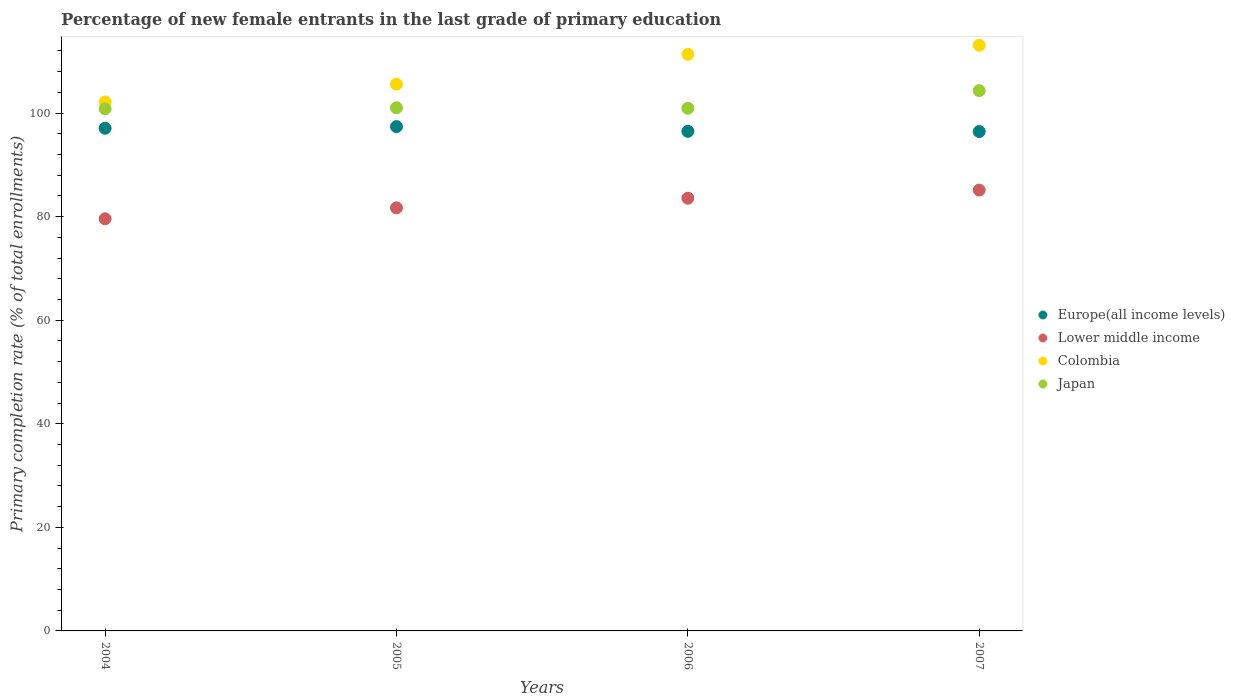Is the number of dotlines equal to the number of legend labels?
Your answer should be compact. Yes. What is the percentage of new female entrants in Japan in 2006?
Provide a short and direct response. 100.92. Across all years, what is the maximum percentage of new female entrants in Japan?
Offer a terse response. 104.33. Across all years, what is the minimum percentage of new female entrants in Colombia?
Your answer should be compact. 102.14. In which year was the percentage of new female entrants in Lower middle income maximum?
Your response must be concise. 2007. What is the total percentage of new female entrants in Lower middle income in the graph?
Provide a short and direct response. 329.95. What is the difference between the percentage of new female entrants in Colombia in 2004 and that in 2006?
Provide a short and direct response. -9.19. What is the difference between the percentage of new female entrants in Europe(all income levels) in 2006 and the percentage of new female entrants in Japan in 2004?
Offer a terse response. -4.35. What is the average percentage of new female entrants in Colombia per year?
Offer a terse response. 108.03. In the year 2005, what is the difference between the percentage of new female entrants in Colombia and percentage of new female entrants in Europe(all income levels)?
Ensure brevity in your answer.  8.2. What is the ratio of the percentage of new female entrants in Lower middle income in 2004 to that in 2005?
Ensure brevity in your answer.  0.97. Is the percentage of new female entrants in Japan in 2006 less than that in 2007?
Give a very brief answer. Yes. What is the difference between the highest and the second highest percentage of new female entrants in Europe(all income levels)?
Your answer should be compact. 0.31. What is the difference between the highest and the lowest percentage of new female entrants in Colombia?
Make the answer very short. 10.94. In how many years, is the percentage of new female entrants in Europe(all income levels) greater than the average percentage of new female entrants in Europe(all income levels) taken over all years?
Offer a very short reply. 2. Is the sum of the percentage of new female entrants in Colombia in 2005 and 2007 greater than the maximum percentage of new female entrants in Lower middle income across all years?
Make the answer very short. Yes. Does the percentage of new female entrants in Europe(all income levels) monotonically increase over the years?
Make the answer very short. No. Is the percentage of new female entrants in Japan strictly greater than the percentage of new female entrants in Colombia over the years?
Make the answer very short. No. Is the percentage of new female entrants in Japan strictly less than the percentage of new female entrants in Colombia over the years?
Your answer should be very brief. Yes. How many dotlines are there?
Your response must be concise. 4. How many years are there in the graph?
Keep it short and to the point. 4. Does the graph contain any zero values?
Ensure brevity in your answer.  No. Does the graph contain grids?
Provide a short and direct response. No. Where does the legend appear in the graph?
Keep it short and to the point. Center right. What is the title of the graph?
Provide a short and direct response. Percentage of new female entrants in the last grade of primary education. What is the label or title of the Y-axis?
Provide a short and direct response. Primary completion rate (% of total enrollments). What is the Primary completion rate (% of total enrollments) in Europe(all income levels) in 2004?
Provide a succinct answer. 97.06. What is the Primary completion rate (% of total enrollments) in Lower middle income in 2004?
Provide a succinct answer. 79.58. What is the Primary completion rate (% of total enrollments) in Colombia in 2004?
Provide a succinct answer. 102.14. What is the Primary completion rate (% of total enrollments) in Japan in 2004?
Your answer should be compact. 100.82. What is the Primary completion rate (% of total enrollments) of Europe(all income levels) in 2005?
Offer a terse response. 97.37. What is the Primary completion rate (% of total enrollments) in Lower middle income in 2005?
Offer a terse response. 81.69. What is the Primary completion rate (% of total enrollments) in Colombia in 2005?
Ensure brevity in your answer.  105.57. What is the Primary completion rate (% of total enrollments) of Japan in 2005?
Your answer should be compact. 101.02. What is the Primary completion rate (% of total enrollments) in Europe(all income levels) in 2006?
Your answer should be very brief. 96.47. What is the Primary completion rate (% of total enrollments) in Lower middle income in 2006?
Ensure brevity in your answer.  83.55. What is the Primary completion rate (% of total enrollments) of Colombia in 2006?
Keep it short and to the point. 111.33. What is the Primary completion rate (% of total enrollments) of Japan in 2006?
Your answer should be very brief. 100.92. What is the Primary completion rate (% of total enrollments) of Europe(all income levels) in 2007?
Your response must be concise. 96.43. What is the Primary completion rate (% of total enrollments) of Lower middle income in 2007?
Make the answer very short. 85.12. What is the Primary completion rate (% of total enrollments) of Colombia in 2007?
Give a very brief answer. 113.09. What is the Primary completion rate (% of total enrollments) in Japan in 2007?
Make the answer very short. 104.33. Across all years, what is the maximum Primary completion rate (% of total enrollments) in Europe(all income levels)?
Offer a very short reply. 97.37. Across all years, what is the maximum Primary completion rate (% of total enrollments) in Lower middle income?
Offer a terse response. 85.12. Across all years, what is the maximum Primary completion rate (% of total enrollments) in Colombia?
Offer a very short reply. 113.09. Across all years, what is the maximum Primary completion rate (% of total enrollments) of Japan?
Ensure brevity in your answer.  104.33. Across all years, what is the minimum Primary completion rate (% of total enrollments) of Europe(all income levels)?
Your response must be concise. 96.43. Across all years, what is the minimum Primary completion rate (% of total enrollments) of Lower middle income?
Your answer should be very brief. 79.58. Across all years, what is the minimum Primary completion rate (% of total enrollments) of Colombia?
Your answer should be very brief. 102.14. Across all years, what is the minimum Primary completion rate (% of total enrollments) of Japan?
Make the answer very short. 100.82. What is the total Primary completion rate (% of total enrollments) of Europe(all income levels) in the graph?
Keep it short and to the point. 387.33. What is the total Primary completion rate (% of total enrollments) of Lower middle income in the graph?
Offer a very short reply. 329.95. What is the total Primary completion rate (% of total enrollments) of Colombia in the graph?
Keep it short and to the point. 432.13. What is the total Primary completion rate (% of total enrollments) of Japan in the graph?
Provide a short and direct response. 407.09. What is the difference between the Primary completion rate (% of total enrollments) of Europe(all income levels) in 2004 and that in 2005?
Keep it short and to the point. -0.31. What is the difference between the Primary completion rate (% of total enrollments) in Lower middle income in 2004 and that in 2005?
Make the answer very short. -2.11. What is the difference between the Primary completion rate (% of total enrollments) of Colombia in 2004 and that in 2005?
Offer a terse response. -3.43. What is the difference between the Primary completion rate (% of total enrollments) in Japan in 2004 and that in 2005?
Provide a succinct answer. -0.2. What is the difference between the Primary completion rate (% of total enrollments) of Europe(all income levels) in 2004 and that in 2006?
Your response must be concise. 0.59. What is the difference between the Primary completion rate (% of total enrollments) in Lower middle income in 2004 and that in 2006?
Your answer should be very brief. -3.97. What is the difference between the Primary completion rate (% of total enrollments) in Colombia in 2004 and that in 2006?
Keep it short and to the point. -9.19. What is the difference between the Primary completion rate (% of total enrollments) of Japan in 2004 and that in 2006?
Keep it short and to the point. -0.1. What is the difference between the Primary completion rate (% of total enrollments) of Europe(all income levels) in 2004 and that in 2007?
Make the answer very short. 0.63. What is the difference between the Primary completion rate (% of total enrollments) of Lower middle income in 2004 and that in 2007?
Your answer should be very brief. -5.54. What is the difference between the Primary completion rate (% of total enrollments) of Colombia in 2004 and that in 2007?
Keep it short and to the point. -10.94. What is the difference between the Primary completion rate (% of total enrollments) of Japan in 2004 and that in 2007?
Offer a terse response. -3.51. What is the difference between the Primary completion rate (% of total enrollments) in Europe(all income levels) in 2005 and that in 2006?
Ensure brevity in your answer.  0.9. What is the difference between the Primary completion rate (% of total enrollments) of Lower middle income in 2005 and that in 2006?
Make the answer very short. -1.86. What is the difference between the Primary completion rate (% of total enrollments) of Colombia in 2005 and that in 2006?
Provide a short and direct response. -5.76. What is the difference between the Primary completion rate (% of total enrollments) of Japan in 2005 and that in 2006?
Keep it short and to the point. 0.1. What is the difference between the Primary completion rate (% of total enrollments) of Europe(all income levels) in 2005 and that in 2007?
Ensure brevity in your answer.  0.94. What is the difference between the Primary completion rate (% of total enrollments) of Lower middle income in 2005 and that in 2007?
Provide a short and direct response. -3.43. What is the difference between the Primary completion rate (% of total enrollments) in Colombia in 2005 and that in 2007?
Your answer should be very brief. -7.52. What is the difference between the Primary completion rate (% of total enrollments) in Japan in 2005 and that in 2007?
Provide a succinct answer. -3.31. What is the difference between the Primary completion rate (% of total enrollments) in Europe(all income levels) in 2006 and that in 2007?
Your response must be concise. 0.04. What is the difference between the Primary completion rate (% of total enrollments) of Lower middle income in 2006 and that in 2007?
Offer a terse response. -1.57. What is the difference between the Primary completion rate (% of total enrollments) of Colombia in 2006 and that in 2007?
Provide a succinct answer. -1.76. What is the difference between the Primary completion rate (% of total enrollments) in Japan in 2006 and that in 2007?
Your answer should be very brief. -3.41. What is the difference between the Primary completion rate (% of total enrollments) of Europe(all income levels) in 2004 and the Primary completion rate (% of total enrollments) of Lower middle income in 2005?
Keep it short and to the point. 15.37. What is the difference between the Primary completion rate (% of total enrollments) in Europe(all income levels) in 2004 and the Primary completion rate (% of total enrollments) in Colombia in 2005?
Give a very brief answer. -8.51. What is the difference between the Primary completion rate (% of total enrollments) in Europe(all income levels) in 2004 and the Primary completion rate (% of total enrollments) in Japan in 2005?
Your answer should be very brief. -3.96. What is the difference between the Primary completion rate (% of total enrollments) in Lower middle income in 2004 and the Primary completion rate (% of total enrollments) in Colombia in 2005?
Provide a succinct answer. -25.99. What is the difference between the Primary completion rate (% of total enrollments) of Lower middle income in 2004 and the Primary completion rate (% of total enrollments) of Japan in 2005?
Your answer should be compact. -21.44. What is the difference between the Primary completion rate (% of total enrollments) in Colombia in 2004 and the Primary completion rate (% of total enrollments) in Japan in 2005?
Your answer should be compact. 1.12. What is the difference between the Primary completion rate (% of total enrollments) in Europe(all income levels) in 2004 and the Primary completion rate (% of total enrollments) in Lower middle income in 2006?
Your answer should be very brief. 13.51. What is the difference between the Primary completion rate (% of total enrollments) of Europe(all income levels) in 2004 and the Primary completion rate (% of total enrollments) of Colombia in 2006?
Provide a succinct answer. -14.27. What is the difference between the Primary completion rate (% of total enrollments) in Europe(all income levels) in 2004 and the Primary completion rate (% of total enrollments) in Japan in 2006?
Ensure brevity in your answer.  -3.86. What is the difference between the Primary completion rate (% of total enrollments) of Lower middle income in 2004 and the Primary completion rate (% of total enrollments) of Colombia in 2006?
Provide a short and direct response. -31.75. What is the difference between the Primary completion rate (% of total enrollments) of Lower middle income in 2004 and the Primary completion rate (% of total enrollments) of Japan in 2006?
Your response must be concise. -21.34. What is the difference between the Primary completion rate (% of total enrollments) in Colombia in 2004 and the Primary completion rate (% of total enrollments) in Japan in 2006?
Your answer should be very brief. 1.23. What is the difference between the Primary completion rate (% of total enrollments) in Europe(all income levels) in 2004 and the Primary completion rate (% of total enrollments) in Lower middle income in 2007?
Offer a terse response. 11.94. What is the difference between the Primary completion rate (% of total enrollments) of Europe(all income levels) in 2004 and the Primary completion rate (% of total enrollments) of Colombia in 2007?
Ensure brevity in your answer.  -16.03. What is the difference between the Primary completion rate (% of total enrollments) in Europe(all income levels) in 2004 and the Primary completion rate (% of total enrollments) in Japan in 2007?
Offer a very short reply. -7.27. What is the difference between the Primary completion rate (% of total enrollments) of Lower middle income in 2004 and the Primary completion rate (% of total enrollments) of Colombia in 2007?
Your response must be concise. -33.51. What is the difference between the Primary completion rate (% of total enrollments) in Lower middle income in 2004 and the Primary completion rate (% of total enrollments) in Japan in 2007?
Make the answer very short. -24.75. What is the difference between the Primary completion rate (% of total enrollments) in Colombia in 2004 and the Primary completion rate (% of total enrollments) in Japan in 2007?
Keep it short and to the point. -2.18. What is the difference between the Primary completion rate (% of total enrollments) in Europe(all income levels) in 2005 and the Primary completion rate (% of total enrollments) in Lower middle income in 2006?
Make the answer very short. 13.82. What is the difference between the Primary completion rate (% of total enrollments) in Europe(all income levels) in 2005 and the Primary completion rate (% of total enrollments) in Colombia in 2006?
Keep it short and to the point. -13.96. What is the difference between the Primary completion rate (% of total enrollments) in Europe(all income levels) in 2005 and the Primary completion rate (% of total enrollments) in Japan in 2006?
Provide a succinct answer. -3.55. What is the difference between the Primary completion rate (% of total enrollments) of Lower middle income in 2005 and the Primary completion rate (% of total enrollments) of Colombia in 2006?
Give a very brief answer. -29.64. What is the difference between the Primary completion rate (% of total enrollments) of Lower middle income in 2005 and the Primary completion rate (% of total enrollments) of Japan in 2006?
Keep it short and to the point. -19.23. What is the difference between the Primary completion rate (% of total enrollments) of Colombia in 2005 and the Primary completion rate (% of total enrollments) of Japan in 2006?
Make the answer very short. 4.65. What is the difference between the Primary completion rate (% of total enrollments) in Europe(all income levels) in 2005 and the Primary completion rate (% of total enrollments) in Lower middle income in 2007?
Keep it short and to the point. 12.25. What is the difference between the Primary completion rate (% of total enrollments) of Europe(all income levels) in 2005 and the Primary completion rate (% of total enrollments) of Colombia in 2007?
Offer a terse response. -15.72. What is the difference between the Primary completion rate (% of total enrollments) of Europe(all income levels) in 2005 and the Primary completion rate (% of total enrollments) of Japan in 2007?
Offer a very short reply. -6.96. What is the difference between the Primary completion rate (% of total enrollments) in Lower middle income in 2005 and the Primary completion rate (% of total enrollments) in Colombia in 2007?
Give a very brief answer. -31.4. What is the difference between the Primary completion rate (% of total enrollments) in Lower middle income in 2005 and the Primary completion rate (% of total enrollments) in Japan in 2007?
Provide a succinct answer. -22.64. What is the difference between the Primary completion rate (% of total enrollments) in Colombia in 2005 and the Primary completion rate (% of total enrollments) in Japan in 2007?
Your answer should be compact. 1.24. What is the difference between the Primary completion rate (% of total enrollments) of Europe(all income levels) in 2006 and the Primary completion rate (% of total enrollments) of Lower middle income in 2007?
Keep it short and to the point. 11.35. What is the difference between the Primary completion rate (% of total enrollments) of Europe(all income levels) in 2006 and the Primary completion rate (% of total enrollments) of Colombia in 2007?
Your answer should be very brief. -16.62. What is the difference between the Primary completion rate (% of total enrollments) of Europe(all income levels) in 2006 and the Primary completion rate (% of total enrollments) of Japan in 2007?
Provide a short and direct response. -7.86. What is the difference between the Primary completion rate (% of total enrollments) in Lower middle income in 2006 and the Primary completion rate (% of total enrollments) in Colombia in 2007?
Keep it short and to the point. -29.53. What is the difference between the Primary completion rate (% of total enrollments) in Lower middle income in 2006 and the Primary completion rate (% of total enrollments) in Japan in 2007?
Ensure brevity in your answer.  -20.77. What is the difference between the Primary completion rate (% of total enrollments) in Colombia in 2006 and the Primary completion rate (% of total enrollments) in Japan in 2007?
Make the answer very short. 7. What is the average Primary completion rate (% of total enrollments) of Europe(all income levels) per year?
Keep it short and to the point. 96.83. What is the average Primary completion rate (% of total enrollments) in Lower middle income per year?
Make the answer very short. 82.49. What is the average Primary completion rate (% of total enrollments) of Colombia per year?
Offer a very short reply. 108.03. What is the average Primary completion rate (% of total enrollments) in Japan per year?
Your answer should be compact. 101.77. In the year 2004, what is the difference between the Primary completion rate (% of total enrollments) in Europe(all income levels) and Primary completion rate (% of total enrollments) in Lower middle income?
Keep it short and to the point. 17.48. In the year 2004, what is the difference between the Primary completion rate (% of total enrollments) in Europe(all income levels) and Primary completion rate (% of total enrollments) in Colombia?
Your answer should be compact. -5.08. In the year 2004, what is the difference between the Primary completion rate (% of total enrollments) in Europe(all income levels) and Primary completion rate (% of total enrollments) in Japan?
Your answer should be compact. -3.76. In the year 2004, what is the difference between the Primary completion rate (% of total enrollments) of Lower middle income and Primary completion rate (% of total enrollments) of Colombia?
Ensure brevity in your answer.  -22.56. In the year 2004, what is the difference between the Primary completion rate (% of total enrollments) of Lower middle income and Primary completion rate (% of total enrollments) of Japan?
Give a very brief answer. -21.24. In the year 2004, what is the difference between the Primary completion rate (% of total enrollments) of Colombia and Primary completion rate (% of total enrollments) of Japan?
Your answer should be very brief. 1.32. In the year 2005, what is the difference between the Primary completion rate (% of total enrollments) of Europe(all income levels) and Primary completion rate (% of total enrollments) of Lower middle income?
Offer a very short reply. 15.68. In the year 2005, what is the difference between the Primary completion rate (% of total enrollments) of Europe(all income levels) and Primary completion rate (% of total enrollments) of Colombia?
Provide a succinct answer. -8.2. In the year 2005, what is the difference between the Primary completion rate (% of total enrollments) in Europe(all income levels) and Primary completion rate (% of total enrollments) in Japan?
Keep it short and to the point. -3.65. In the year 2005, what is the difference between the Primary completion rate (% of total enrollments) of Lower middle income and Primary completion rate (% of total enrollments) of Colombia?
Provide a short and direct response. -23.88. In the year 2005, what is the difference between the Primary completion rate (% of total enrollments) of Lower middle income and Primary completion rate (% of total enrollments) of Japan?
Provide a short and direct response. -19.33. In the year 2005, what is the difference between the Primary completion rate (% of total enrollments) in Colombia and Primary completion rate (% of total enrollments) in Japan?
Keep it short and to the point. 4.55. In the year 2006, what is the difference between the Primary completion rate (% of total enrollments) in Europe(all income levels) and Primary completion rate (% of total enrollments) in Lower middle income?
Your response must be concise. 12.92. In the year 2006, what is the difference between the Primary completion rate (% of total enrollments) of Europe(all income levels) and Primary completion rate (% of total enrollments) of Colombia?
Your answer should be compact. -14.86. In the year 2006, what is the difference between the Primary completion rate (% of total enrollments) of Europe(all income levels) and Primary completion rate (% of total enrollments) of Japan?
Your response must be concise. -4.45. In the year 2006, what is the difference between the Primary completion rate (% of total enrollments) of Lower middle income and Primary completion rate (% of total enrollments) of Colombia?
Keep it short and to the point. -27.77. In the year 2006, what is the difference between the Primary completion rate (% of total enrollments) in Lower middle income and Primary completion rate (% of total enrollments) in Japan?
Keep it short and to the point. -17.36. In the year 2006, what is the difference between the Primary completion rate (% of total enrollments) of Colombia and Primary completion rate (% of total enrollments) of Japan?
Provide a short and direct response. 10.41. In the year 2007, what is the difference between the Primary completion rate (% of total enrollments) in Europe(all income levels) and Primary completion rate (% of total enrollments) in Lower middle income?
Ensure brevity in your answer.  11.31. In the year 2007, what is the difference between the Primary completion rate (% of total enrollments) of Europe(all income levels) and Primary completion rate (% of total enrollments) of Colombia?
Give a very brief answer. -16.66. In the year 2007, what is the difference between the Primary completion rate (% of total enrollments) of Europe(all income levels) and Primary completion rate (% of total enrollments) of Japan?
Your answer should be compact. -7.9. In the year 2007, what is the difference between the Primary completion rate (% of total enrollments) in Lower middle income and Primary completion rate (% of total enrollments) in Colombia?
Ensure brevity in your answer.  -27.96. In the year 2007, what is the difference between the Primary completion rate (% of total enrollments) in Lower middle income and Primary completion rate (% of total enrollments) in Japan?
Keep it short and to the point. -19.2. In the year 2007, what is the difference between the Primary completion rate (% of total enrollments) in Colombia and Primary completion rate (% of total enrollments) in Japan?
Your answer should be very brief. 8.76. What is the ratio of the Primary completion rate (% of total enrollments) in Lower middle income in 2004 to that in 2005?
Provide a succinct answer. 0.97. What is the ratio of the Primary completion rate (% of total enrollments) in Colombia in 2004 to that in 2005?
Your answer should be compact. 0.97. What is the ratio of the Primary completion rate (% of total enrollments) of Japan in 2004 to that in 2005?
Ensure brevity in your answer.  1. What is the ratio of the Primary completion rate (% of total enrollments) in Europe(all income levels) in 2004 to that in 2006?
Provide a short and direct response. 1.01. What is the ratio of the Primary completion rate (% of total enrollments) of Colombia in 2004 to that in 2006?
Provide a succinct answer. 0.92. What is the ratio of the Primary completion rate (% of total enrollments) of Japan in 2004 to that in 2006?
Keep it short and to the point. 1. What is the ratio of the Primary completion rate (% of total enrollments) of Lower middle income in 2004 to that in 2007?
Make the answer very short. 0.93. What is the ratio of the Primary completion rate (% of total enrollments) of Colombia in 2004 to that in 2007?
Your answer should be very brief. 0.9. What is the ratio of the Primary completion rate (% of total enrollments) of Japan in 2004 to that in 2007?
Provide a succinct answer. 0.97. What is the ratio of the Primary completion rate (% of total enrollments) of Europe(all income levels) in 2005 to that in 2006?
Your answer should be very brief. 1.01. What is the ratio of the Primary completion rate (% of total enrollments) in Lower middle income in 2005 to that in 2006?
Offer a very short reply. 0.98. What is the ratio of the Primary completion rate (% of total enrollments) in Colombia in 2005 to that in 2006?
Give a very brief answer. 0.95. What is the ratio of the Primary completion rate (% of total enrollments) of Japan in 2005 to that in 2006?
Your answer should be compact. 1. What is the ratio of the Primary completion rate (% of total enrollments) in Europe(all income levels) in 2005 to that in 2007?
Your answer should be compact. 1.01. What is the ratio of the Primary completion rate (% of total enrollments) of Lower middle income in 2005 to that in 2007?
Provide a short and direct response. 0.96. What is the ratio of the Primary completion rate (% of total enrollments) of Colombia in 2005 to that in 2007?
Offer a terse response. 0.93. What is the ratio of the Primary completion rate (% of total enrollments) of Japan in 2005 to that in 2007?
Your answer should be compact. 0.97. What is the ratio of the Primary completion rate (% of total enrollments) in Lower middle income in 2006 to that in 2007?
Ensure brevity in your answer.  0.98. What is the ratio of the Primary completion rate (% of total enrollments) in Colombia in 2006 to that in 2007?
Your response must be concise. 0.98. What is the ratio of the Primary completion rate (% of total enrollments) in Japan in 2006 to that in 2007?
Provide a short and direct response. 0.97. What is the difference between the highest and the second highest Primary completion rate (% of total enrollments) of Europe(all income levels)?
Your answer should be very brief. 0.31. What is the difference between the highest and the second highest Primary completion rate (% of total enrollments) of Lower middle income?
Your answer should be very brief. 1.57. What is the difference between the highest and the second highest Primary completion rate (% of total enrollments) of Colombia?
Provide a short and direct response. 1.76. What is the difference between the highest and the second highest Primary completion rate (% of total enrollments) in Japan?
Ensure brevity in your answer.  3.31. What is the difference between the highest and the lowest Primary completion rate (% of total enrollments) in Europe(all income levels)?
Your answer should be compact. 0.94. What is the difference between the highest and the lowest Primary completion rate (% of total enrollments) in Lower middle income?
Your response must be concise. 5.54. What is the difference between the highest and the lowest Primary completion rate (% of total enrollments) of Colombia?
Provide a short and direct response. 10.94. What is the difference between the highest and the lowest Primary completion rate (% of total enrollments) of Japan?
Provide a succinct answer. 3.51. 